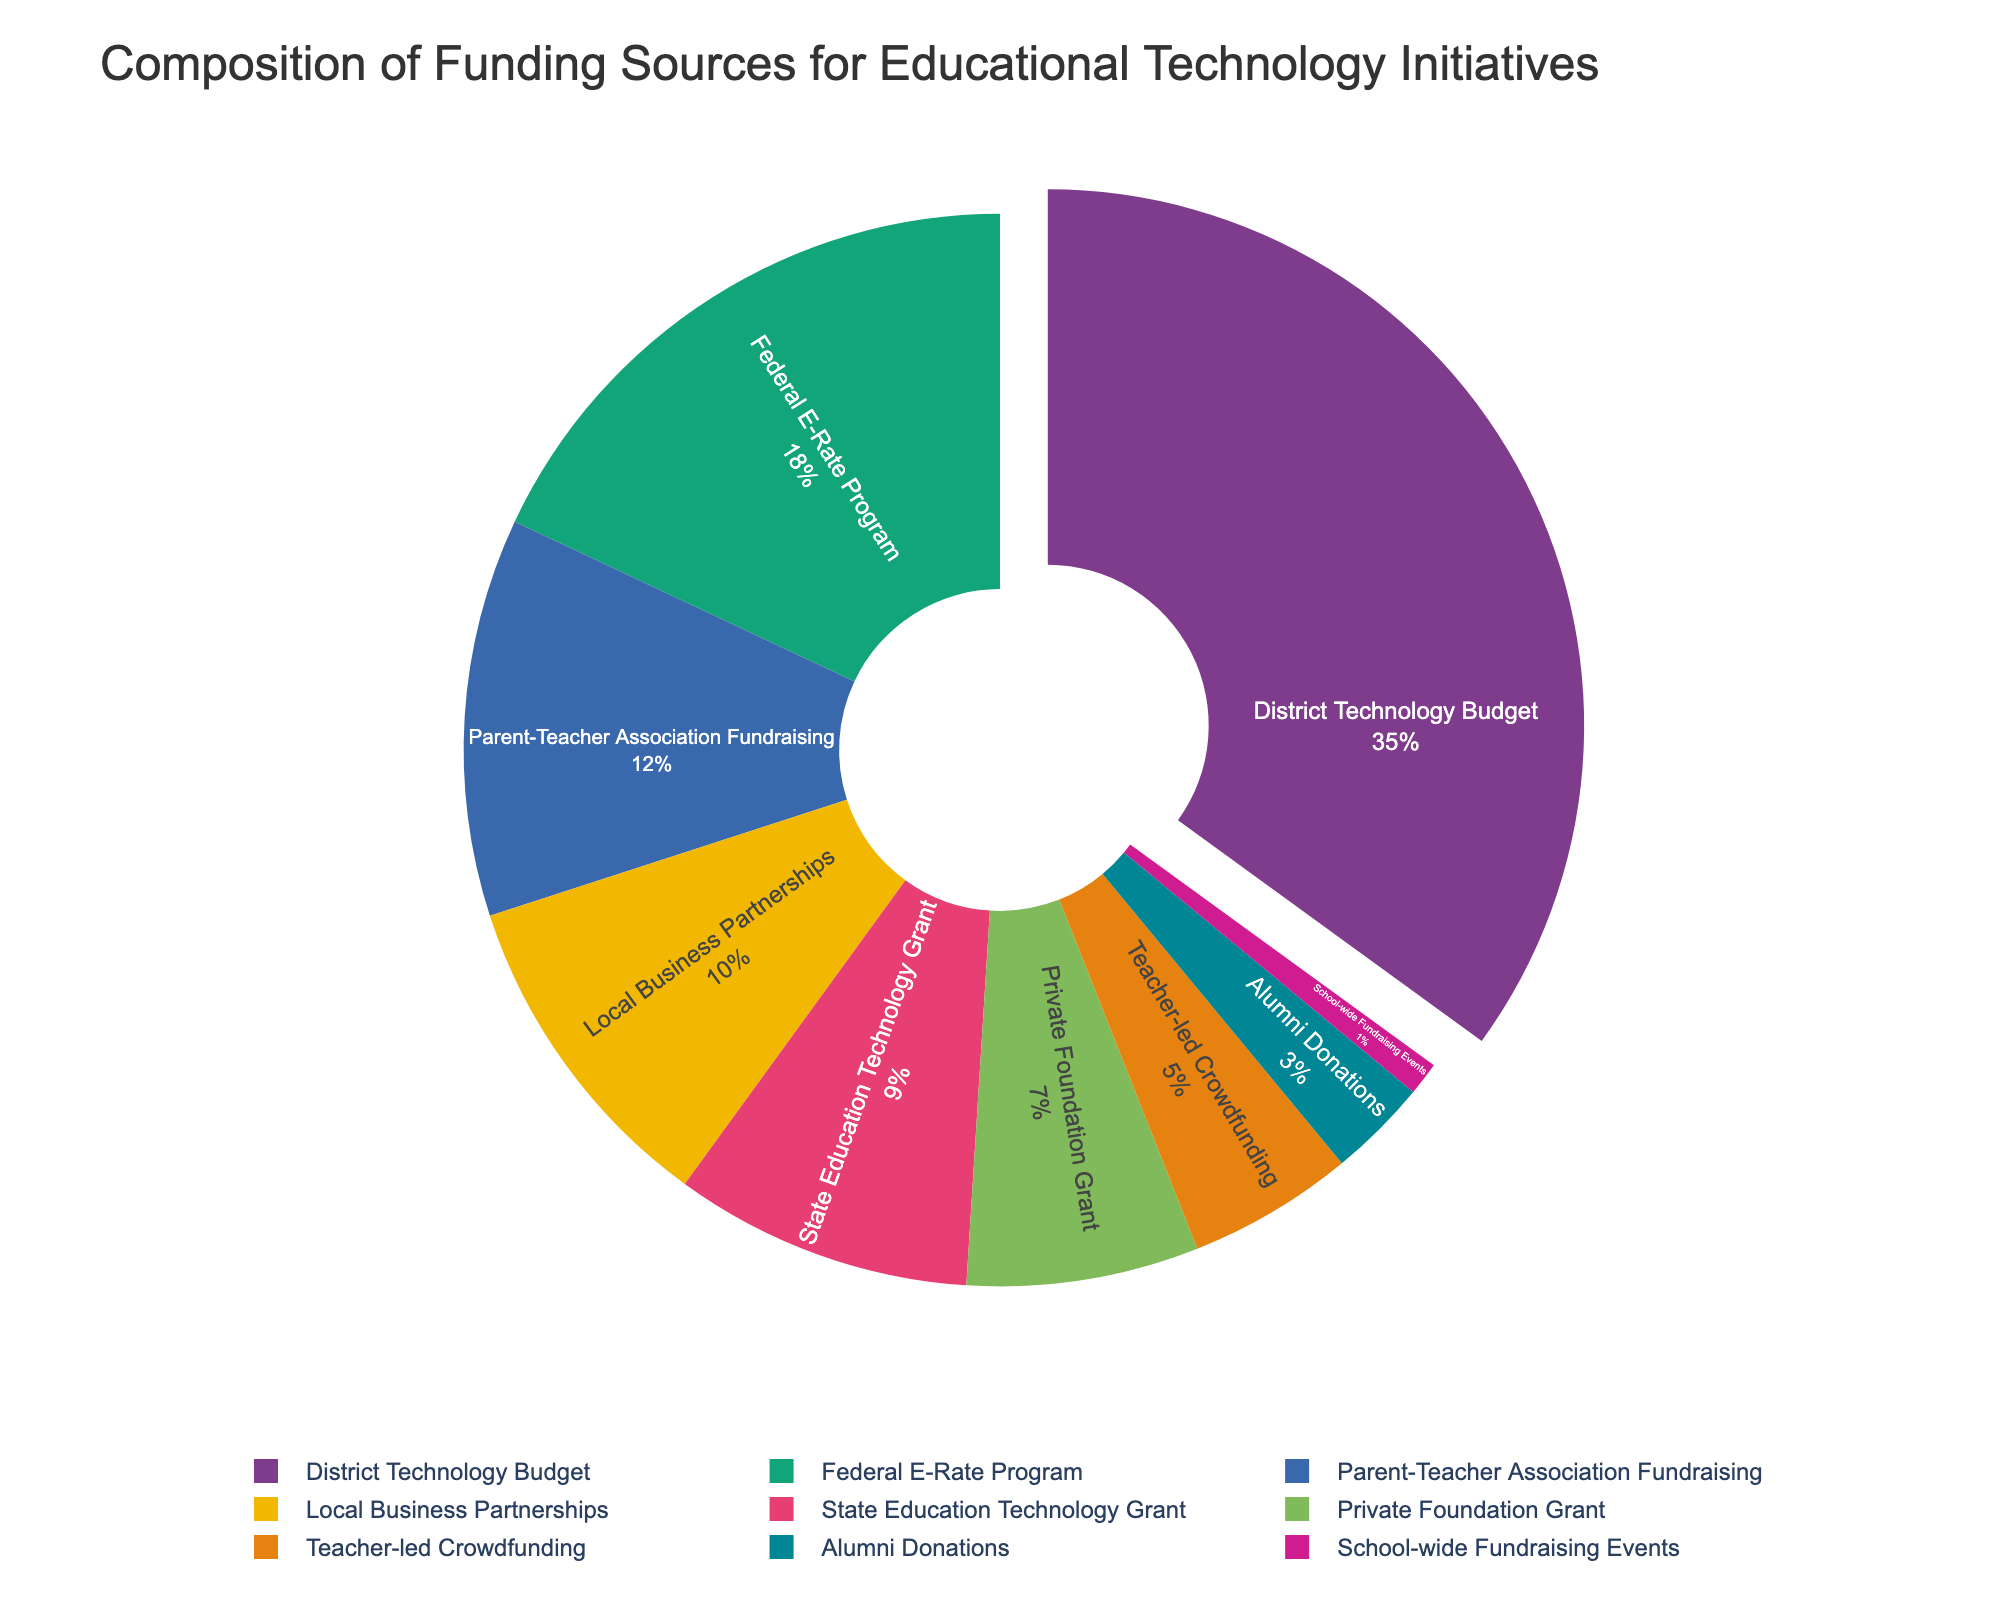Which funding source has the highest contribution to the educational technology initiatives? The pie chart clearly shows the largest segment with the highest percentage. The 'District Technology Budget' segment appears the largest.
Answer: District Technology Budget What is the total percentage contribution of 'Local Business Partnerships' and 'Parent-Teacher Association Fundraising'? To find the total percentage, add the percentages of 'Local Business Partnerships' (10%) and 'Parent-Teacher Association Fundraising' (12%). 10% + 12% = 22%.
Answer: 22% Which funding source has the smallest contribution, and what is its percentage? The smallest segment of the pie chart represents 'School-wide Fundraising Events' with a contribution of 1%.
Answer: School-wide Fundraising Events, 1% Compare the contributions of the 'Federal E-Rate Program' and the 'State Education Technology Grant'. The pie chart shows that the 'Federal E-Rate Program' contributes 18% whereas the 'State Education Technology Grant' contributes 9%. 18% is greater than 9%.
Answer: Federal E-Rate Program, 18% > 9% What is the difference in percentage between the contributions from 'Private Foundation Grant' and 'Alumni Donations'? The pie chart indicates that 'Private Foundation Grant' contributes 7%, and 'Alumni Donations' contributes 3%. The difference is 7% - 3% = 4%.
Answer: 4% Is the percentage contributed by 'Teacher-led Crowdfunding' more than that of 'School-wide Fundraising Events'? According to the pie chart, 'Teacher-led Crowdfunding' contributes 5%, whereas 'School-wide Fundraising Events' contribute 1%. 5% is greater than 1%.
Answer: Yes What is the combined percentage contribution of all sources excluding the top contributor? To find this, exclude the percentage of the 'District Technology Budget' (35%) and sum up the remaining percentages: 18% + 12% + 10% + 9% + 7% + 5% + 3% + 1% = 65%.
Answer: 65% Describe how the 'Federal E-Rate Program' segment is visually distinguished in the pie chart. The 'Federal E-Rate Program' segment is identifiable by its position and color on the chart. It is the second-largest segment and might be represented by a distinct color from the vibrant palette used.
Answer: Distinct color, second-largest segment From the funding sources that contribute less than 10%, which one has the maximum contribution and what is it? Among the funding sources contributing less than 10%, 'State Education Technology Grant' contributes the most, with 9%.
Answer: State Education Technology Grant, 9% What is the average percentage contribution of the 'Local Business Partnerships', 'Alumni Donations', and 'State Education Technology Grant'? Sum the percentages of these sources and divide by the number of sources: (10% + 3% + 9%) / 3 = 22% / 3 ≈ 7.33%.
Answer: 7.33% 